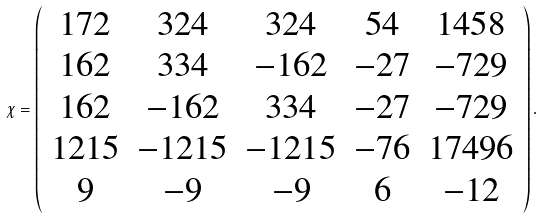Convert formula to latex. <formula><loc_0><loc_0><loc_500><loc_500>\chi = { \left ( \begin{array} { c c c c c } 1 7 2 & 3 2 4 & 3 2 4 & 5 4 & 1 4 5 8 \\ 1 6 2 & 3 3 4 & - 1 6 2 & - 2 7 & - 7 2 9 \\ 1 6 2 & - 1 6 2 & 3 3 4 & - 2 7 & - 7 2 9 \\ 1 2 1 5 & - 1 2 1 5 & - 1 2 1 5 & - 7 6 & 1 7 4 9 6 \\ 9 & - 9 & - 9 & 6 & - 1 2 \end{array} \right ) } \, .</formula> 